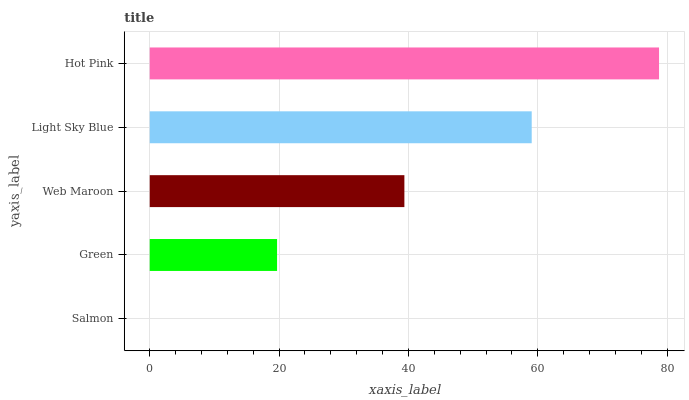Is Salmon the minimum?
Answer yes or no. Yes. Is Hot Pink the maximum?
Answer yes or no. Yes. Is Green the minimum?
Answer yes or no. No. Is Green the maximum?
Answer yes or no. No. Is Green greater than Salmon?
Answer yes or no. Yes. Is Salmon less than Green?
Answer yes or no. Yes. Is Salmon greater than Green?
Answer yes or no. No. Is Green less than Salmon?
Answer yes or no. No. Is Web Maroon the high median?
Answer yes or no. Yes. Is Web Maroon the low median?
Answer yes or no. Yes. Is Salmon the high median?
Answer yes or no. No. Is Hot Pink the low median?
Answer yes or no. No. 